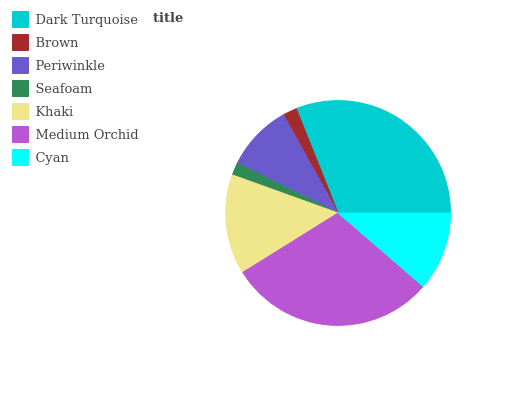Is Seafoam the minimum?
Answer yes or no. Yes. Is Dark Turquoise the maximum?
Answer yes or no. Yes. Is Brown the minimum?
Answer yes or no. No. Is Brown the maximum?
Answer yes or no. No. Is Dark Turquoise greater than Brown?
Answer yes or no. Yes. Is Brown less than Dark Turquoise?
Answer yes or no. Yes. Is Brown greater than Dark Turquoise?
Answer yes or no. No. Is Dark Turquoise less than Brown?
Answer yes or no. No. Is Cyan the high median?
Answer yes or no. Yes. Is Cyan the low median?
Answer yes or no. Yes. Is Khaki the high median?
Answer yes or no. No. Is Brown the low median?
Answer yes or no. No. 